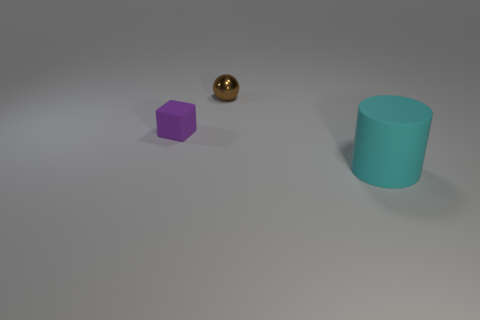Add 1 tiny brown spheres. How many objects exist? 4 Subtract all cylinders. How many objects are left? 2 Add 3 brown metallic things. How many brown metallic things exist? 4 Subtract 0 brown cylinders. How many objects are left? 3 Subtract all small purple things. Subtract all metal spheres. How many objects are left? 1 Add 3 small purple matte blocks. How many small purple matte blocks are left? 4 